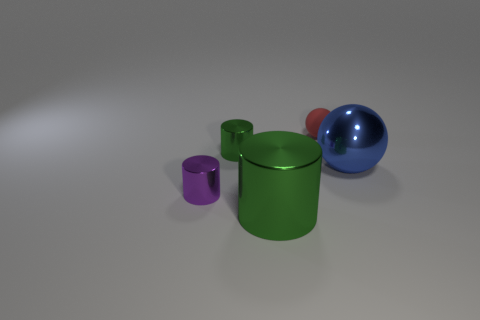Add 2 large blue shiny things. How many objects exist? 7 Subtract all cylinders. How many objects are left? 2 Add 1 big blue balls. How many big blue balls exist? 2 Subtract 0 cyan balls. How many objects are left? 5 Subtract all small red spheres. Subtract all metallic objects. How many objects are left? 0 Add 1 purple shiny objects. How many purple shiny objects are left? 2 